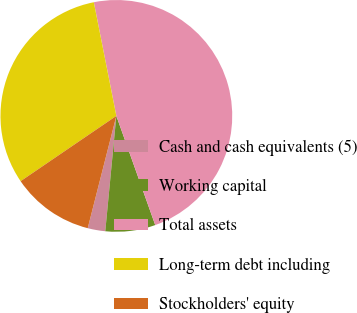Convert chart to OTSL. <chart><loc_0><loc_0><loc_500><loc_500><pie_chart><fcel>Cash and cash equivalents (5)<fcel>Working capital<fcel>Total assets<fcel>Long-term debt including<fcel>Stockholders' equity<nl><fcel>2.45%<fcel>6.97%<fcel>47.67%<fcel>31.41%<fcel>11.5%<nl></chart> 